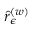Convert formula to latex. <formula><loc_0><loc_0><loc_500><loc_500>\hat { r } _ { \epsilon } ^ { \left ( w \right ) }</formula> 